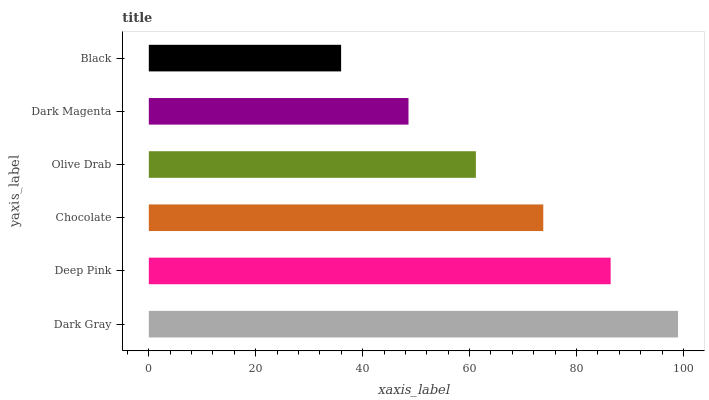Is Black the minimum?
Answer yes or no. Yes. Is Dark Gray the maximum?
Answer yes or no. Yes. Is Deep Pink the minimum?
Answer yes or no. No. Is Deep Pink the maximum?
Answer yes or no. No. Is Dark Gray greater than Deep Pink?
Answer yes or no. Yes. Is Deep Pink less than Dark Gray?
Answer yes or no. Yes. Is Deep Pink greater than Dark Gray?
Answer yes or no. No. Is Dark Gray less than Deep Pink?
Answer yes or no. No. Is Chocolate the high median?
Answer yes or no. Yes. Is Olive Drab the low median?
Answer yes or no. Yes. Is Deep Pink the high median?
Answer yes or no. No. Is Chocolate the low median?
Answer yes or no. No. 